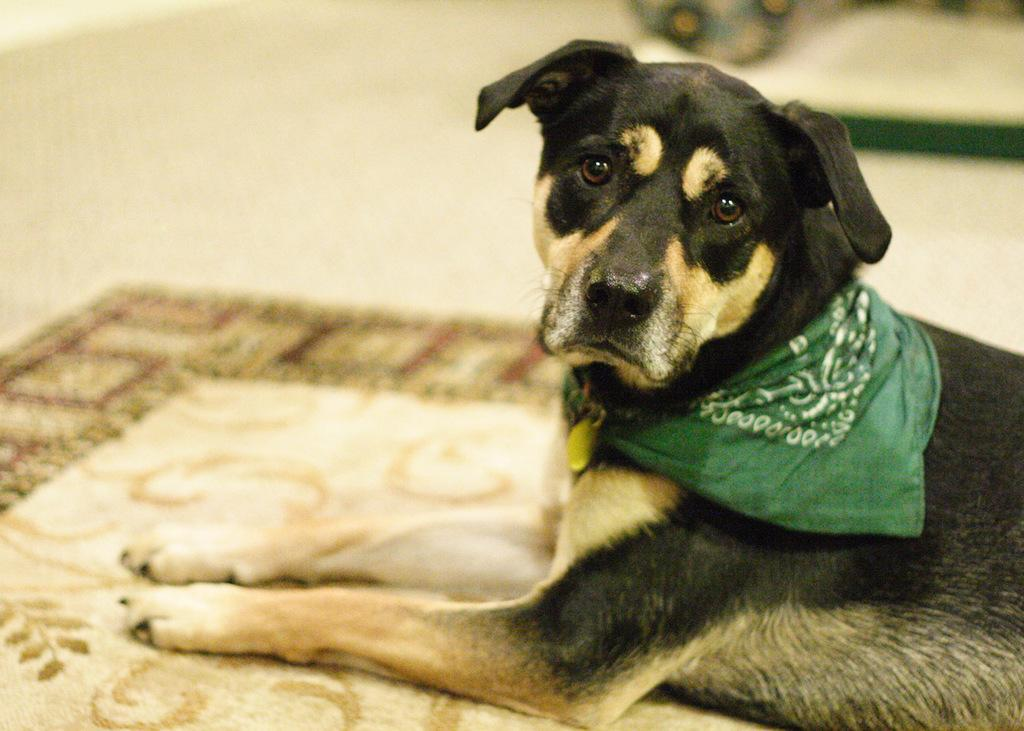Where was the image taken? The image was taken in a house. What is in the foreground of the image? There is a dog in the foreground of the image. What is at the bottom of the image? There is a mat at the bottom of the image. How would you describe the background of the image? The background of the image is blurred. What type of grape is the dog eating in the image? There is no grape present in the image, and the dog is not eating anything. What punishment is being given to the dog in the image? There is no indication of punishment in the image; the dog appears to be in a relaxed position. 